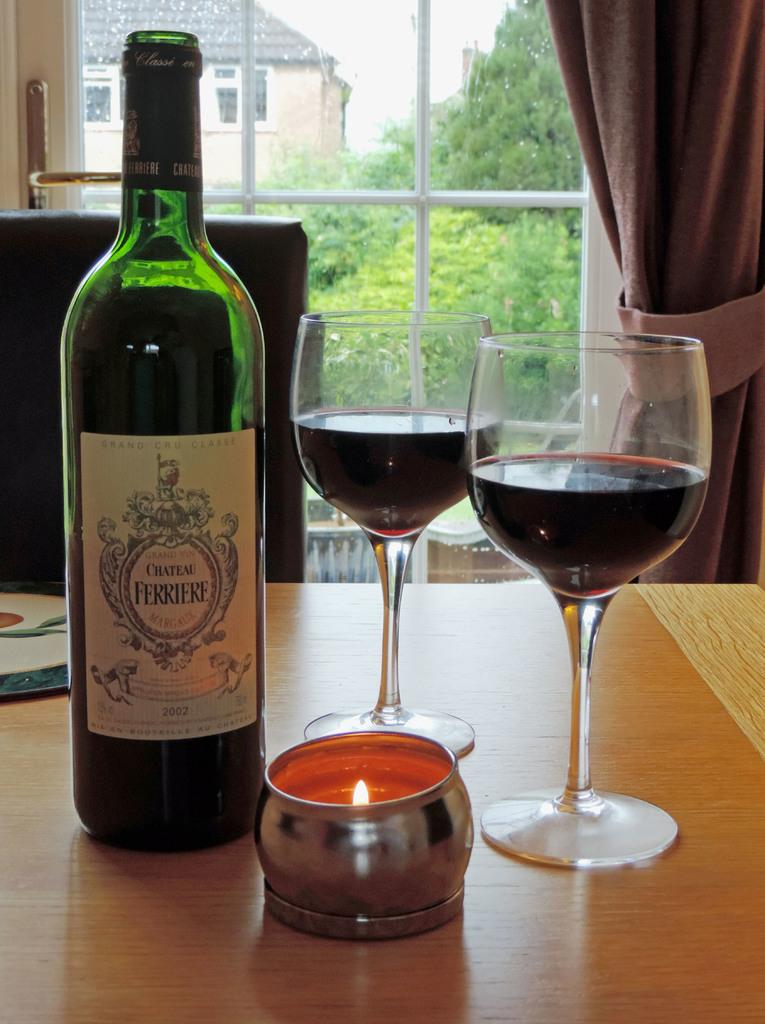<image>
Give a short and clear explanation of the subsequent image. A bottle of Chateau Ferriere wine on a table with two wine glasses. 